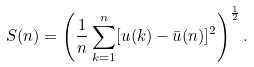<formula> <loc_0><loc_0><loc_500><loc_500>S ( n ) = \left ( \frac { 1 } { n } \sum _ { k = 1 } ^ { n } [ u ( k ) - \bar { u } ( n ) ] ^ { 2 } \right ) ^ { \frac { 1 } { 2 } } .</formula> 